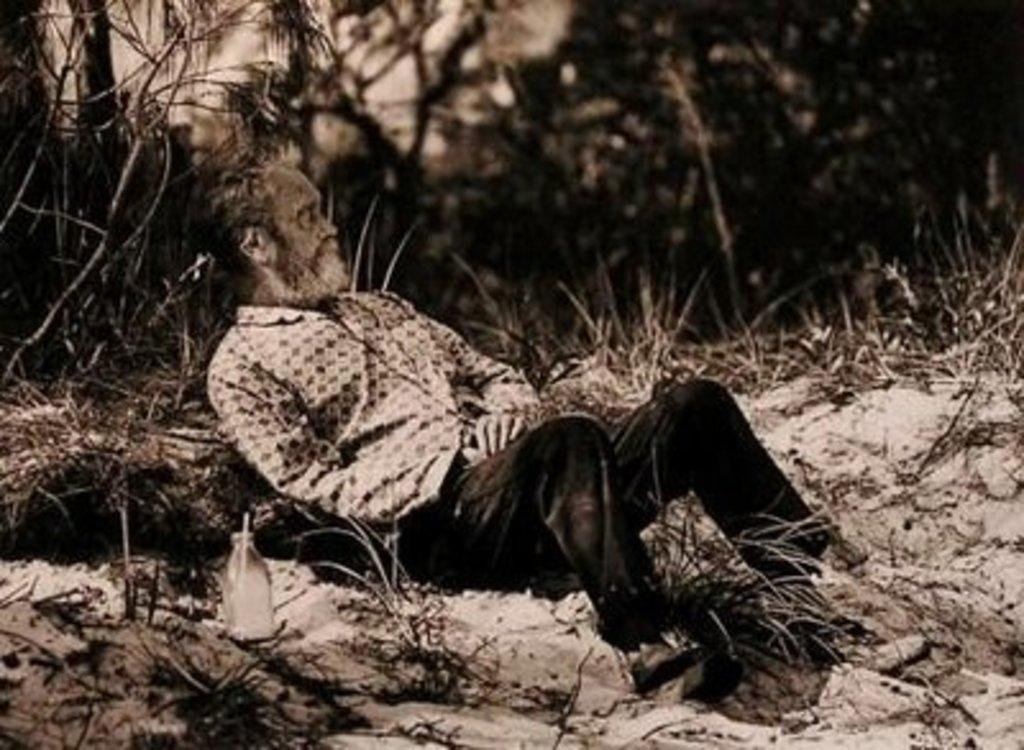Can you describe this image briefly? This is a black and white image. In this image we can see a person lying on the ground and a bottle beside him. We can also see some plants, a group of trees and the sky. 